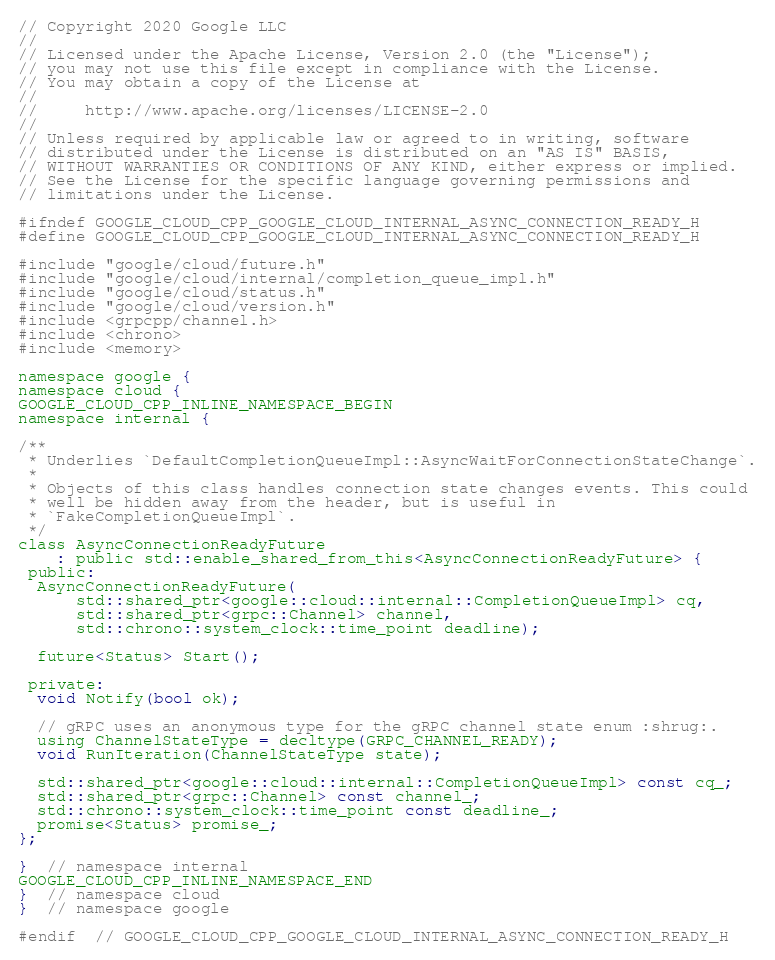<code> <loc_0><loc_0><loc_500><loc_500><_C_>// Copyright 2020 Google LLC
//
// Licensed under the Apache License, Version 2.0 (the "License");
// you may not use this file except in compliance with the License.
// You may obtain a copy of the License at
//
//     http://www.apache.org/licenses/LICENSE-2.0
//
// Unless required by applicable law or agreed to in writing, software
// distributed under the License is distributed on an "AS IS" BASIS,
// WITHOUT WARRANTIES OR CONDITIONS OF ANY KIND, either express or implied.
// See the License for the specific language governing permissions and
// limitations under the License.

#ifndef GOOGLE_CLOUD_CPP_GOOGLE_CLOUD_INTERNAL_ASYNC_CONNECTION_READY_H
#define GOOGLE_CLOUD_CPP_GOOGLE_CLOUD_INTERNAL_ASYNC_CONNECTION_READY_H

#include "google/cloud/future.h"
#include "google/cloud/internal/completion_queue_impl.h"
#include "google/cloud/status.h"
#include "google/cloud/version.h"
#include <grpcpp/channel.h>
#include <chrono>
#include <memory>

namespace google {
namespace cloud {
GOOGLE_CLOUD_CPP_INLINE_NAMESPACE_BEGIN
namespace internal {

/**
 * Underlies `DefaultCompletionQueueImpl::AsyncWaitForConnectionStateChange`.
 *
 * Objects of this class handles connection state changes events. This could
 * well be hidden away from the header, but is useful in
 * `FakeCompletionQueueImpl`.
 */
class AsyncConnectionReadyFuture
    : public std::enable_shared_from_this<AsyncConnectionReadyFuture> {
 public:
  AsyncConnectionReadyFuture(
      std::shared_ptr<google::cloud::internal::CompletionQueueImpl> cq,
      std::shared_ptr<grpc::Channel> channel,
      std::chrono::system_clock::time_point deadline);

  future<Status> Start();

 private:
  void Notify(bool ok);

  // gRPC uses an anonymous type for the gRPC channel state enum :shrug:.
  using ChannelStateType = decltype(GRPC_CHANNEL_READY);
  void RunIteration(ChannelStateType state);

  std::shared_ptr<google::cloud::internal::CompletionQueueImpl> const cq_;
  std::shared_ptr<grpc::Channel> const channel_;
  std::chrono::system_clock::time_point const deadline_;
  promise<Status> promise_;
};

}  // namespace internal
GOOGLE_CLOUD_CPP_INLINE_NAMESPACE_END
}  // namespace cloud
}  // namespace google

#endif  // GOOGLE_CLOUD_CPP_GOOGLE_CLOUD_INTERNAL_ASYNC_CONNECTION_READY_H
</code> 